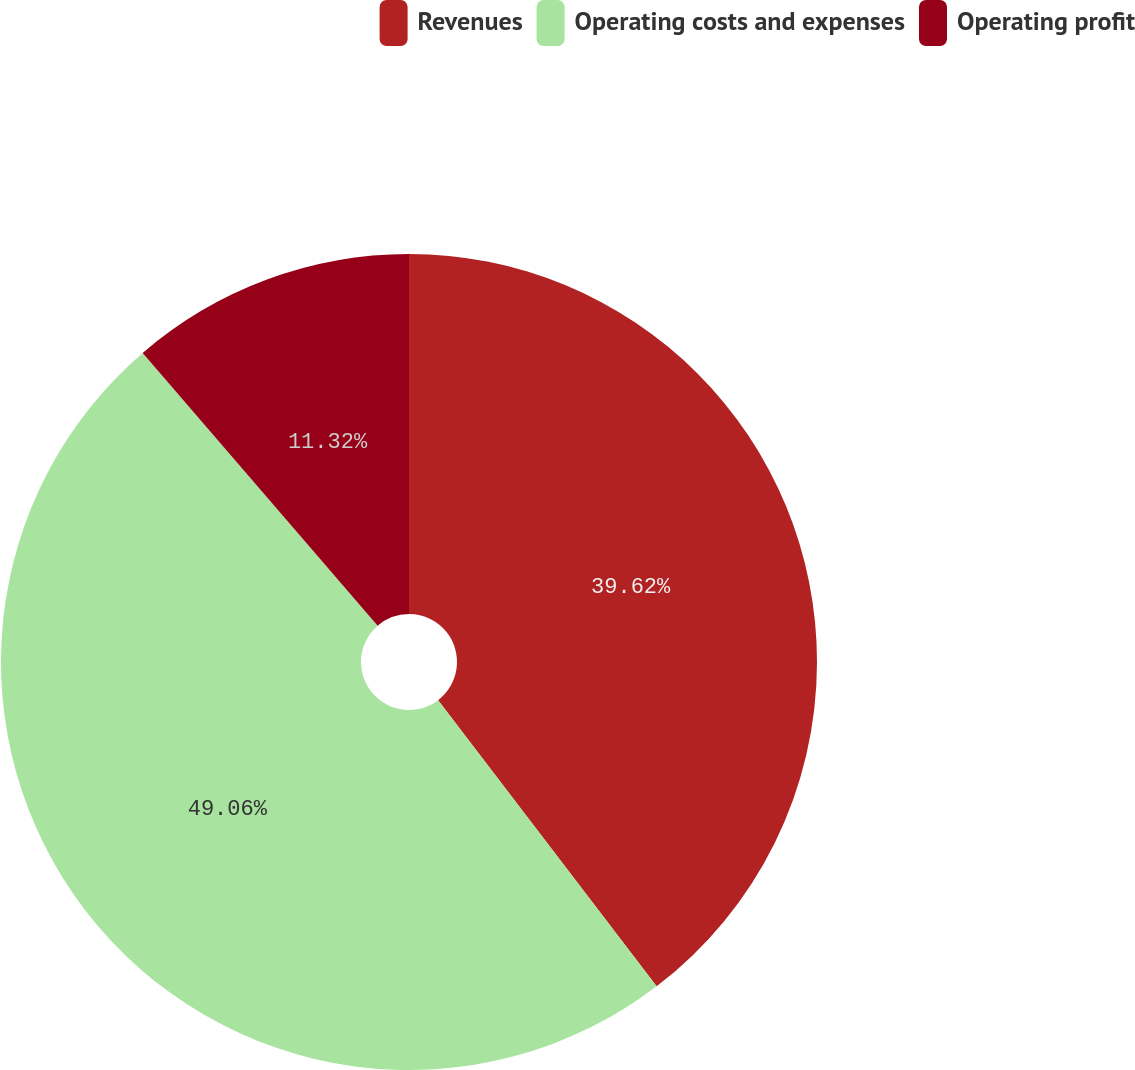<chart> <loc_0><loc_0><loc_500><loc_500><pie_chart><fcel>Revenues<fcel>Operating costs and expenses<fcel>Operating profit<nl><fcel>39.62%<fcel>49.06%<fcel>11.32%<nl></chart> 